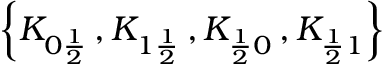Convert formula to latex. <formula><loc_0><loc_0><loc_500><loc_500>\left \{ K _ { 0 \frac { 1 } { 2 } } \, , K _ { 1 \frac { 1 } { 2 } } \, , K _ { \frac { 1 } { 2 } 0 } \, , K _ { \frac { 1 } { 2 } 1 } \right \}</formula> 